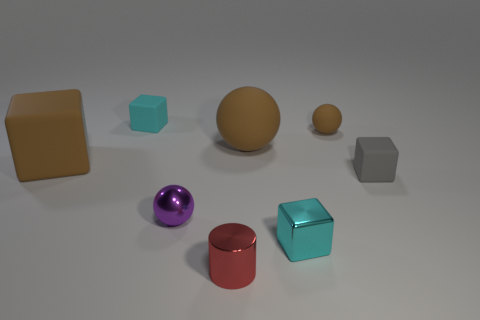The thing that is both on the left side of the tiny brown sphere and on the right side of the large brown sphere has what shape?
Provide a short and direct response. Cube. Is there a cylinder that is behind the tiny matte block right of the tiny matte block to the left of the red metallic object?
Offer a terse response. No. How big is the rubber thing that is both behind the gray object and right of the large sphere?
Make the answer very short. Small. What number of small red cylinders have the same material as the brown cube?
Offer a terse response. 0. How many cylinders are either big purple rubber things or big brown objects?
Make the answer very short. 0. What size is the rubber block in front of the brown thing that is in front of the big brown matte ball that is on the right side of the small red metal cylinder?
Offer a terse response. Small. What color is the matte object that is both in front of the small brown rubber sphere and to the left of the tiny purple object?
Provide a short and direct response. Brown. There is a red shiny cylinder; does it have the same size as the metallic object on the left side of the red shiny object?
Offer a very short reply. Yes. Are there any other things that have the same shape as the tiny cyan rubber thing?
Make the answer very short. Yes. What color is the other large object that is the same shape as the cyan metal object?
Offer a very short reply. Brown. 